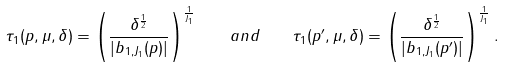Convert formula to latex. <formula><loc_0><loc_0><loc_500><loc_500>\tau _ { 1 } ( p , \mu , \delta ) = \left ( \frac { \delta ^ { \frac { 1 } { 2 } } } { | b _ { 1 , J _ { 1 } } ( p ) | } \right ) ^ { \frac { 1 } { J _ { 1 } } } \quad a n d \quad \tau _ { 1 } ( p ^ { \prime } , \mu , \delta ) = \left ( \frac { \delta ^ { \frac { 1 } { 2 } } } { | b _ { 1 , J _ { 1 } } ( p ^ { \prime } ) | } \right ) ^ { \frac { 1 } { J _ { 1 } } } .</formula> 